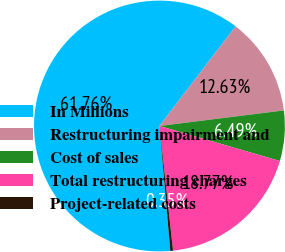Convert chart to OTSL. <chart><loc_0><loc_0><loc_500><loc_500><pie_chart><fcel>In Millions<fcel>Restructuring impairment and<fcel>Cost of sales<fcel>Total restructuring charges<fcel>Project-related costs<nl><fcel>61.77%<fcel>12.63%<fcel>6.49%<fcel>18.77%<fcel>0.35%<nl></chart> 